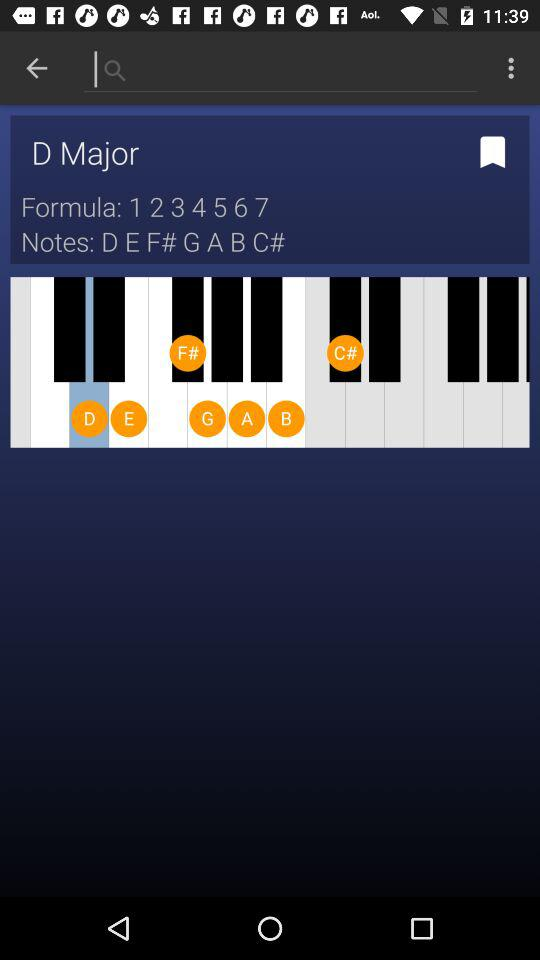What is the formula that the user employs? The formula that the user employs is 1234567. 